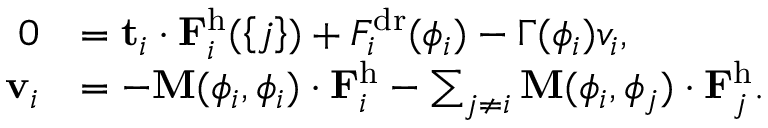Convert formula to latex. <formula><loc_0><loc_0><loc_500><loc_500>\begin{array} { r l } { 0 } & { = t _ { i } \cdot F _ { i } ^ { h } ( \left \{ j \right \} ) + F _ { i } ^ { d r } ( \phi _ { i } ) - \Gamma ( \phi _ { i } ) v _ { i } , } \\ { v _ { i } } & { = - M ( \phi _ { i } , \phi _ { i } ) \cdot F _ { i } ^ { h } - \sum _ { j \ne i } M ( \phi _ { i } , \phi _ { j } ) \cdot F _ { j } ^ { h } . } \end{array}</formula> 